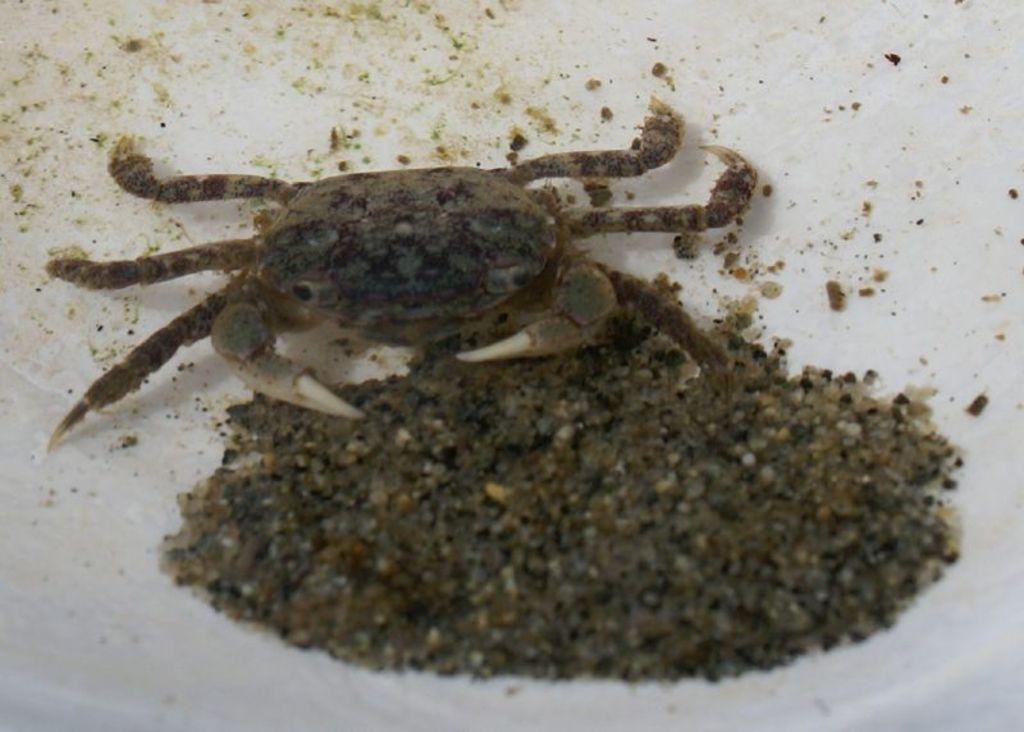Please provide a concise description of this image. In this image I can see an insect. To the side I can see the mud. It is on the white color surface. 